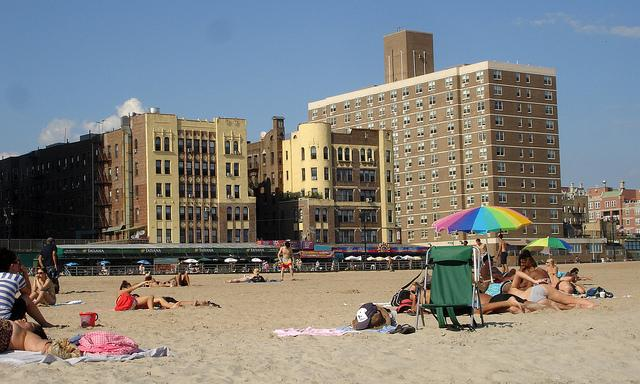Where is someone who might easily overheat safest here?

Choices:
A) on chair
B) under umbrella
C) in sand
D) water's edge under umbrella 